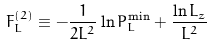<formula> <loc_0><loc_0><loc_500><loc_500>F _ { L } ^ { ( 2 ) } \equiv - \frac { 1 } { 2 L ^ { 2 } } \ln P _ { L } ^ { \min } + \frac { \ln L _ { z } } { L ^ { 2 } }</formula> 